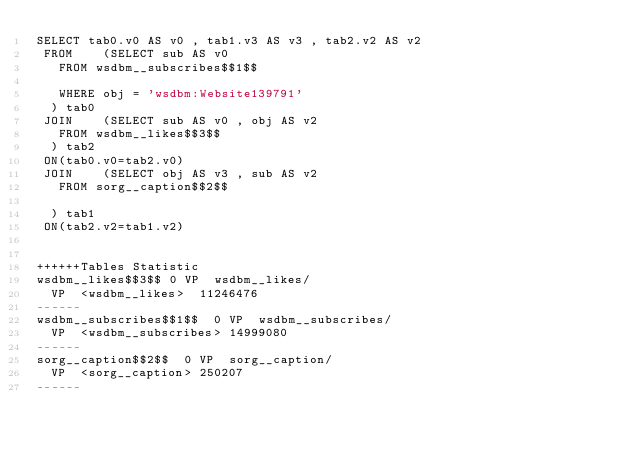<code> <loc_0><loc_0><loc_500><loc_500><_SQL_>SELECT tab0.v0 AS v0 , tab1.v3 AS v3 , tab2.v2 AS v2 
 FROM    (SELECT sub AS v0 
	 FROM wsdbm__subscribes$$1$$
	 
	 WHERE obj = 'wsdbm:Website139791'
	) tab0
 JOIN    (SELECT sub AS v0 , obj AS v2 
	 FROM wsdbm__likes$$3$$
	) tab2
 ON(tab0.v0=tab2.v0)
 JOIN    (SELECT obj AS v3 , sub AS v2 
	 FROM sorg__caption$$2$$
	
	) tab1
 ON(tab2.v2=tab1.v2)


++++++Tables Statistic
wsdbm__likes$$3$$	0	VP	wsdbm__likes/
	VP	<wsdbm__likes>	11246476
------
wsdbm__subscribes$$1$$	0	VP	wsdbm__subscribes/
	VP	<wsdbm__subscribes>	14999080
------
sorg__caption$$2$$	0	VP	sorg__caption/
	VP	<sorg__caption>	250207
------
</code> 